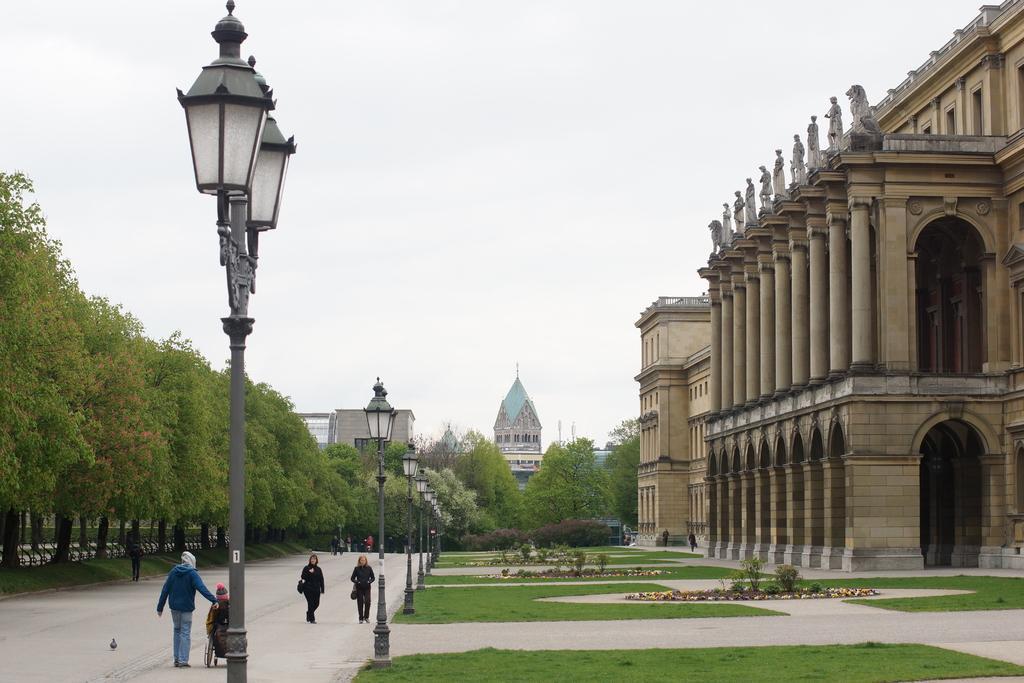Describe this image in one or two sentences. At the bottom of the picture, we see people walking on the road. Beside them, we see street lights or lamp poles. We even see the grass. On the right side, we see a building and beside that, two people are walking. On the left side, we see trees. There are trees and buildings in the background. At the top of the picture, we see the sky. 